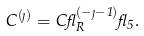<formula> <loc_0><loc_0><loc_500><loc_500>C ^ { ( \eta ) } = C \gamma _ { R } ^ { ( - \eta - 1 ) } \gamma _ { 5 } .</formula> 